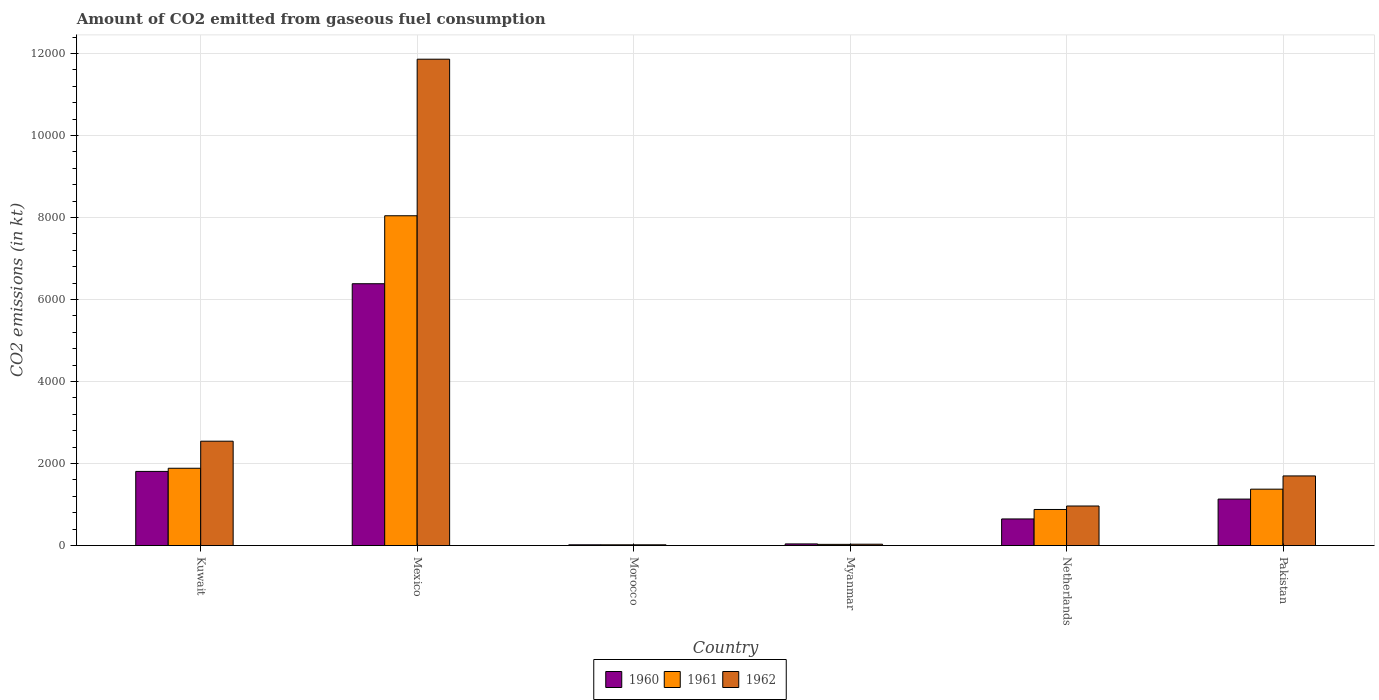How many groups of bars are there?
Your answer should be very brief. 6. Are the number of bars on each tick of the X-axis equal?
Provide a succinct answer. Yes. How many bars are there on the 4th tick from the left?
Offer a very short reply. 3. What is the label of the 2nd group of bars from the left?
Give a very brief answer. Mexico. What is the amount of CO2 emitted in 1961 in Mexico?
Your response must be concise. 8041.73. Across all countries, what is the maximum amount of CO2 emitted in 1962?
Offer a terse response. 1.19e+04. Across all countries, what is the minimum amount of CO2 emitted in 1960?
Provide a succinct answer. 18.34. In which country was the amount of CO2 emitted in 1962 minimum?
Provide a succinct answer. Morocco. What is the total amount of CO2 emitted in 1961 in the graph?
Keep it short and to the point. 1.22e+04. What is the difference between the amount of CO2 emitted in 1960 in Mexico and that in Pakistan?
Your answer should be compact. 5251.14. What is the difference between the amount of CO2 emitted in 1961 in Kuwait and the amount of CO2 emitted in 1962 in Morocco?
Offer a very short reply. 1866.5. What is the average amount of CO2 emitted in 1961 per country?
Offer a very short reply. 2038.24. What is the difference between the amount of CO2 emitted of/in 1961 and amount of CO2 emitted of/in 1962 in Morocco?
Give a very brief answer. 0. In how many countries, is the amount of CO2 emitted in 1961 greater than 10800 kt?
Give a very brief answer. 0. What is the ratio of the amount of CO2 emitted in 1962 in Mexico to that in Myanmar?
Keep it short and to the point. 359.33. Is the amount of CO2 emitted in 1960 in Kuwait less than that in Pakistan?
Make the answer very short. No. Is the difference between the amount of CO2 emitted in 1961 in Mexico and Pakistan greater than the difference between the amount of CO2 emitted in 1962 in Mexico and Pakistan?
Offer a very short reply. No. What is the difference between the highest and the second highest amount of CO2 emitted in 1961?
Offer a terse response. 6156.89. What is the difference between the highest and the lowest amount of CO2 emitted in 1961?
Your answer should be compact. 8023.4. What does the 1st bar from the left in Mexico represents?
Keep it short and to the point. 1960. Is it the case that in every country, the sum of the amount of CO2 emitted in 1962 and amount of CO2 emitted in 1960 is greater than the amount of CO2 emitted in 1961?
Your response must be concise. Yes. Are the values on the major ticks of Y-axis written in scientific E-notation?
Ensure brevity in your answer.  No. Does the graph contain any zero values?
Ensure brevity in your answer.  No. How many legend labels are there?
Keep it short and to the point. 3. How are the legend labels stacked?
Give a very brief answer. Horizontal. What is the title of the graph?
Make the answer very short. Amount of CO2 emitted from gaseous fuel consumption. Does "1985" appear as one of the legend labels in the graph?
Your answer should be very brief. No. What is the label or title of the Y-axis?
Your answer should be compact. CO2 emissions (in kt). What is the CO2 emissions (in kt) of 1960 in Kuwait?
Offer a terse response. 1807.83. What is the CO2 emissions (in kt) of 1961 in Kuwait?
Your answer should be very brief. 1884.84. What is the CO2 emissions (in kt) of 1962 in Kuwait?
Provide a short and direct response. 2544.9. What is the CO2 emissions (in kt) in 1960 in Mexico?
Ensure brevity in your answer.  6384.25. What is the CO2 emissions (in kt) in 1961 in Mexico?
Offer a terse response. 8041.73. What is the CO2 emissions (in kt) of 1962 in Mexico?
Provide a short and direct response. 1.19e+04. What is the CO2 emissions (in kt) in 1960 in Morocco?
Provide a short and direct response. 18.34. What is the CO2 emissions (in kt) of 1961 in Morocco?
Keep it short and to the point. 18.34. What is the CO2 emissions (in kt) in 1962 in Morocco?
Your response must be concise. 18.34. What is the CO2 emissions (in kt) in 1960 in Myanmar?
Offer a very short reply. 40.34. What is the CO2 emissions (in kt) of 1961 in Myanmar?
Provide a short and direct response. 29.34. What is the CO2 emissions (in kt) of 1962 in Myanmar?
Give a very brief answer. 33. What is the CO2 emissions (in kt) of 1960 in Netherlands?
Provide a short and direct response. 649.06. What is the CO2 emissions (in kt) of 1961 in Netherlands?
Your response must be concise. 880.08. What is the CO2 emissions (in kt) of 1962 in Netherlands?
Give a very brief answer. 964.42. What is the CO2 emissions (in kt) in 1960 in Pakistan?
Your response must be concise. 1133.1. What is the CO2 emissions (in kt) in 1961 in Pakistan?
Provide a short and direct response. 1375.12. What is the CO2 emissions (in kt) in 1962 in Pakistan?
Offer a very short reply. 1697.82. Across all countries, what is the maximum CO2 emissions (in kt) in 1960?
Offer a very short reply. 6384.25. Across all countries, what is the maximum CO2 emissions (in kt) in 1961?
Your response must be concise. 8041.73. Across all countries, what is the maximum CO2 emissions (in kt) of 1962?
Your answer should be compact. 1.19e+04. Across all countries, what is the minimum CO2 emissions (in kt) of 1960?
Your answer should be very brief. 18.34. Across all countries, what is the minimum CO2 emissions (in kt) of 1961?
Ensure brevity in your answer.  18.34. Across all countries, what is the minimum CO2 emissions (in kt) in 1962?
Make the answer very short. 18.34. What is the total CO2 emissions (in kt) of 1960 in the graph?
Provide a succinct answer. 1.00e+04. What is the total CO2 emissions (in kt) in 1961 in the graph?
Your answer should be very brief. 1.22e+04. What is the total CO2 emissions (in kt) of 1962 in the graph?
Ensure brevity in your answer.  1.71e+04. What is the difference between the CO2 emissions (in kt) in 1960 in Kuwait and that in Mexico?
Your response must be concise. -4576.42. What is the difference between the CO2 emissions (in kt) of 1961 in Kuwait and that in Mexico?
Your response must be concise. -6156.89. What is the difference between the CO2 emissions (in kt) in 1962 in Kuwait and that in Mexico?
Make the answer very short. -9314.18. What is the difference between the CO2 emissions (in kt) of 1960 in Kuwait and that in Morocco?
Your answer should be compact. 1789.5. What is the difference between the CO2 emissions (in kt) in 1961 in Kuwait and that in Morocco?
Give a very brief answer. 1866.5. What is the difference between the CO2 emissions (in kt) of 1962 in Kuwait and that in Morocco?
Offer a very short reply. 2526.56. What is the difference between the CO2 emissions (in kt) in 1960 in Kuwait and that in Myanmar?
Provide a succinct answer. 1767.49. What is the difference between the CO2 emissions (in kt) in 1961 in Kuwait and that in Myanmar?
Make the answer very short. 1855.5. What is the difference between the CO2 emissions (in kt) of 1962 in Kuwait and that in Myanmar?
Offer a terse response. 2511.89. What is the difference between the CO2 emissions (in kt) in 1960 in Kuwait and that in Netherlands?
Your answer should be very brief. 1158.77. What is the difference between the CO2 emissions (in kt) in 1961 in Kuwait and that in Netherlands?
Offer a terse response. 1004.76. What is the difference between the CO2 emissions (in kt) of 1962 in Kuwait and that in Netherlands?
Your response must be concise. 1580.48. What is the difference between the CO2 emissions (in kt) of 1960 in Kuwait and that in Pakistan?
Ensure brevity in your answer.  674.73. What is the difference between the CO2 emissions (in kt) in 1961 in Kuwait and that in Pakistan?
Provide a succinct answer. 509.71. What is the difference between the CO2 emissions (in kt) of 1962 in Kuwait and that in Pakistan?
Make the answer very short. 847.08. What is the difference between the CO2 emissions (in kt) of 1960 in Mexico and that in Morocco?
Provide a succinct answer. 6365.91. What is the difference between the CO2 emissions (in kt) of 1961 in Mexico and that in Morocco?
Your answer should be very brief. 8023.4. What is the difference between the CO2 emissions (in kt) of 1962 in Mexico and that in Morocco?
Give a very brief answer. 1.18e+04. What is the difference between the CO2 emissions (in kt) in 1960 in Mexico and that in Myanmar?
Provide a succinct answer. 6343.91. What is the difference between the CO2 emissions (in kt) of 1961 in Mexico and that in Myanmar?
Give a very brief answer. 8012.4. What is the difference between the CO2 emissions (in kt) of 1962 in Mexico and that in Myanmar?
Ensure brevity in your answer.  1.18e+04. What is the difference between the CO2 emissions (in kt) in 1960 in Mexico and that in Netherlands?
Provide a short and direct response. 5735.19. What is the difference between the CO2 emissions (in kt) of 1961 in Mexico and that in Netherlands?
Provide a succinct answer. 7161.65. What is the difference between the CO2 emissions (in kt) in 1962 in Mexico and that in Netherlands?
Provide a short and direct response. 1.09e+04. What is the difference between the CO2 emissions (in kt) of 1960 in Mexico and that in Pakistan?
Offer a terse response. 5251.14. What is the difference between the CO2 emissions (in kt) in 1961 in Mexico and that in Pakistan?
Your response must be concise. 6666.61. What is the difference between the CO2 emissions (in kt) of 1962 in Mexico and that in Pakistan?
Your answer should be very brief. 1.02e+04. What is the difference between the CO2 emissions (in kt) in 1960 in Morocco and that in Myanmar?
Offer a terse response. -22. What is the difference between the CO2 emissions (in kt) of 1961 in Morocco and that in Myanmar?
Provide a succinct answer. -11. What is the difference between the CO2 emissions (in kt) of 1962 in Morocco and that in Myanmar?
Provide a short and direct response. -14.67. What is the difference between the CO2 emissions (in kt) in 1960 in Morocco and that in Netherlands?
Provide a succinct answer. -630.72. What is the difference between the CO2 emissions (in kt) of 1961 in Morocco and that in Netherlands?
Provide a succinct answer. -861.75. What is the difference between the CO2 emissions (in kt) of 1962 in Morocco and that in Netherlands?
Keep it short and to the point. -946.09. What is the difference between the CO2 emissions (in kt) of 1960 in Morocco and that in Pakistan?
Your answer should be very brief. -1114.77. What is the difference between the CO2 emissions (in kt) of 1961 in Morocco and that in Pakistan?
Offer a terse response. -1356.79. What is the difference between the CO2 emissions (in kt) in 1962 in Morocco and that in Pakistan?
Offer a very short reply. -1679.49. What is the difference between the CO2 emissions (in kt) of 1960 in Myanmar and that in Netherlands?
Make the answer very short. -608.72. What is the difference between the CO2 emissions (in kt) in 1961 in Myanmar and that in Netherlands?
Offer a very short reply. -850.74. What is the difference between the CO2 emissions (in kt) in 1962 in Myanmar and that in Netherlands?
Give a very brief answer. -931.42. What is the difference between the CO2 emissions (in kt) of 1960 in Myanmar and that in Pakistan?
Offer a terse response. -1092.77. What is the difference between the CO2 emissions (in kt) of 1961 in Myanmar and that in Pakistan?
Offer a terse response. -1345.79. What is the difference between the CO2 emissions (in kt) in 1962 in Myanmar and that in Pakistan?
Make the answer very short. -1664.82. What is the difference between the CO2 emissions (in kt) of 1960 in Netherlands and that in Pakistan?
Your answer should be very brief. -484.04. What is the difference between the CO2 emissions (in kt) of 1961 in Netherlands and that in Pakistan?
Provide a short and direct response. -495.05. What is the difference between the CO2 emissions (in kt) in 1962 in Netherlands and that in Pakistan?
Offer a terse response. -733.4. What is the difference between the CO2 emissions (in kt) in 1960 in Kuwait and the CO2 emissions (in kt) in 1961 in Mexico?
Make the answer very short. -6233.9. What is the difference between the CO2 emissions (in kt) in 1960 in Kuwait and the CO2 emissions (in kt) in 1962 in Mexico?
Your response must be concise. -1.01e+04. What is the difference between the CO2 emissions (in kt) in 1961 in Kuwait and the CO2 emissions (in kt) in 1962 in Mexico?
Your response must be concise. -9974.24. What is the difference between the CO2 emissions (in kt) in 1960 in Kuwait and the CO2 emissions (in kt) in 1961 in Morocco?
Give a very brief answer. 1789.5. What is the difference between the CO2 emissions (in kt) of 1960 in Kuwait and the CO2 emissions (in kt) of 1962 in Morocco?
Your response must be concise. 1789.5. What is the difference between the CO2 emissions (in kt) in 1961 in Kuwait and the CO2 emissions (in kt) in 1962 in Morocco?
Give a very brief answer. 1866.5. What is the difference between the CO2 emissions (in kt) of 1960 in Kuwait and the CO2 emissions (in kt) of 1961 in Myanmar?
Provide a short and direct response. 1778.49. What is the difference between the CO2 emissions (in kt) of 1960 in Kuwait and the CO2 emissions (in kt) of 1962 in Myanmar?
Provide a succinct answer. 1774.83. What is the difference between the CO2 emissions (in kt) of 1961 in Kuwait and the CO2 emissions (in kt) of 1962 in Myanmar?
Offer a terse response. 1851.84. What is the difference between the CO2 emissions (in kt) in 1960 in Kuwait and the CO2 emissions (in kt) in 1961 in Netherlands?
Offer a very short reply. 927.75. What is the difference between the CO2 emissions (in kt) in 1960 in Kuwait and the CO2 emissions (in kt) in 1962 in Netherlands?
Provide a short and direct response. 843.41. What is the difference between the CO2 emissions (in kt) in 1961 in Kuwait and the CO2 emissions (in kt) in 1962 in Netherlands?
Give a very brief answer. 920.42. What is the difference between the CO2 emissions (in kt) of 1960 in Kuwait and the CO2 emissions (in kt) of 1961 in Pakistan?
Offer a terse response. 432.71. What is the difference between the CO2 emissions (in kt) of 1960 in Kuwait and the CO2 emissions (in kt) of 1962 in Pakistan?
Offer a terse response. 110.01. What is the difference between the CO2 emissions (in kt) in 1961 in Kuwait and the CO2 emissions (in kt) in 1962 in Pakistan?
Your answer should be compact. 187.02. What is the difference between the CO2 emissions (in kt) of 1960 in Mexico and the CO2 emissions (in kt) of 1961 in Morocco?
Offer a very short reply. 6365.91. What is the difference between the CO2 emissions (in kt) of 1960 in Mexico and the CO2 emissions (in kt) of 1962 in Morocco?
Make the answer very short. 6365.91. What is the difference between the CO2 emissions (in kt) in 1961 in Mexico and the CO2 emissions (in kt) in 1962 in Morocco?
Offer a very short reply. 8023.4. What is the difference between the CO2 emissions (in kt) of 1960 in Mexico and the CO2 emissions (in kt) of 1961 in Myanmar?
Offer a terse response. 6354.91. What is the difference between the CO2 emissions (in kt) of 1960 in Mexico and the CO2 emissions (in kt) of 1962 in Myanmar?
Keep it short and to the point. 6351.24. What is the difference between the CO2 emissions (in kt) in 1961 in Mexico and the CO2 emissions (in kt) in 1962 in Myanmar?
Your answer should be compact. 8008.73. What is the difference between the CO2 emissions (in kt) in 1960 in Mexico and the CO2 emissions (in kt) in 1961 in Netherlands?
Ensure brevity in your answer.  5504.17. What is the difference between the CO2 emissions (in kt) in 1960 in Mexico and the CO2 emissions (in kt) in 1962 in Netherlands?
Give a very brief answer. 5419.83. What is the difference between the CO2 emissions (in kt) in 1961 in Mexico and the CO2 emissions (in kt) in 1962 in Netherlands?
Make the answer very short. 7077.31. What is the difference between the CO2 emissions (in kt) of 1960 in Mexico and the CO2 emissions (in kt) of 1961 in Pakistan?
Provide a short and direct response. 5009.12. What is the difference between the CO2 emissions (in kt) in 1960 in Mexico and the CO2 emissions (in kt) in 1962 in Pakistan?
Your answer should be compact. 4686.43. What is the difference between the CO2 emissions (in kt) of 1961 in Mexico and the CO2 emissions (in kt) of 1962 in Pakistan?
Offer a terse response. 6343.91. What is the difference between the CO2 emissions (in kt) in 1960 in Morocco and the CO2 emissions (in kt) in 1961 in Myanmar?
Your response must be concise. -11. What is the difference between the CO2 emissions (in kt) in 1960 in Morocco and the CO2 emissions (in kt) in 1962 in Myanmar?
Your answer should be very brief. -14.67. What is the difference between the CO2 emissions (in kt) of 1961 in Morocco and the CO2 emissions (in kt) of 1962 in Myanmar?
Provide a short and direct response. -14.67. What is the difference between the CO2 emissions (in kt) in 1960 in Morocco and the CO2 emissions (in kt) in 1961 in Netherlands?
Your answer should be compact. -861.75. What is the difference between the CO2 emissions (in kt) of 1960 in Morocco and the CO2 emissions (in kt) of 1962 in Netherlands?
Your answer should be compact. -946.09. What is the difference between the CO2 emissions (in kt) of 1961 in Morocco and the CO2 emissions (in kt) of 1962 in Netherlands?
Your answer should be compact. -946.09. What is the difference between the CO2 emissions (in kt) of 1960 in Morocco and the CO2 emissions (in kt) of 1961 in Pakistan?
Provide a succinct answer. -1356.79. What is the difference between the CO2 emissions (in kt) in 1960 in Morocco and the CO2 emissions (in kt) in 1962 in Pakistan?
Give a very brief answer. -1679.49. What is the difference between the CO2 emissions (in kt) in 1961 in Morocco and the CO2 emissions (in kt) in 1962 in Pakistan?
Offer a very short reply. -1679.49. What is the difference between the CO2 emissions (in kt) in 1960 in Myanmar and the CO2 emissions (in kt) in 1961 in Netherlands?
Your answer should be compact. -839.74. What is the difference between the CO2 emissions (in kt) in 1960 in Myanmar and the CO2 emissions (in kt) in 1962 in Netherlands?
Give a very brief answer. -924.08. What is the difference between the CO2 emissions (in kt) in 1961 in Myanmar and the CO2 emissions (in kt) in 1962 in Netherlands?
Your answer should be very brief. -935.09. What is the difference between the CO2 emissions (in kt) in 1960 in Myanmar and the CO2 emissions (in kt) in 1961 in Pakistan?
Your answer should be compact. -1334.79. What is the difference between the CO2 emissions (in kt) of 1960 in Myanmar and the CO2 emissions (in kt) of 1962 in Pakistan?
Your response must be concise. -1657.48. What is the difference between the CO2 emissions (in kt) in 1961 in Myanmar and the CO2 emissions (in kt) in 1962 in Pakistan?
Offer a terse response. -1668.48. What is the difference between the CO2 emissions (in kt) in 1960 in Netherlands and the CO2 emissions (in kt) in 1961 in Pakistan?
Your answer should be very brief. -726.07. What is the difference between the CO2 emissions (in kt) in 1960 in Netherlands and the CO2 emissions (in kt) in 1962 in Pakistan?
Your answer should be compact. -1048.76. What is the difference between the CO2 emissions (in kt) in 1961 in Netherlands and the CO2 emissions (in kt) in 1962 in Pakistan?
Your answer should be very brief. -817.74. What is the average CO2 emissions (in kt) in 1960 per country?
Offer a very short reply. 1672.15. What is the average CO2 emissions (in kt) in 1961 per country?
Give a very brief answer. 2038.24. What is the average CO2 emissions (in kt) in 1962 per country?
Ensure brevity in your answer.  2852.93. What is the difference between the CO2 emissions (in kt) of 1960 and CO2 emissions (in kt) of 1961 in Kuwait?
Ensure brevity in your answer.  -77.01. What is the difference between the CO2 emissions (in kt) of 1960 and CO2 emissions (in kt) of 1962 in Kuwait?
Make the answer very short. -737.07. What is the difference between the CO2 emissions (in kt) of 1961 and CO2 emissions (in kt) of 1962 in Kuwait?
Provide a succinct answer. -660.06. What is the difference between the CO2 emissions (in kt) of 1960 and CO2 emissions (in kt) of 1961 in Mexico?
Give a very brief answer. -1657.48. What is the difference between the CO2 emissions (in kt) of 1960 and CO2 emissions (in kt) of 1962 in Mexico?
Your answer should be compact. -5474.83. What is the difference between the CO2 emissions (in kt) in 1961 and CO2 emissions (in kt) in 1962 in Mexico?
Your response must be concise. -3817.35. What is the difference between the CO2 emissions (in kt) in 1961 and CO2 emissions (in kt) in 1962 in Morocco?
Ensure brevity in your answer.  0. What is the difference between the CO2 emissions (in kt) in 1960 and CO2 emissions (in kt) in 1961 in Myanmar?
Offer a terse response. 11. What is the difference between the CO2 emissions (in kt) of 1960 and CO2 emissions (in kt) of 1962 in Myanmar?
Provide a succinct answer. 7.33. What is the difference between the CO2 emissions (in kt) in 1961 and CO2 emissions (in kt) in 1962 in Myanmar?
Make the answer very short. -3.67. What is the difference between the CO2 emissions (in kt) of 1960 and CO2 emissions (in kt) of 1961 in Netherlands?
Your answer should be very brief. -231.02. What is the difference between the CO2 emissions (in kt) of 1960 and CO2 emissions (in kt) of 1962 in Netherlands?
Ensure brevity in your answer.  -315.36. What is the difference between the CO2 emissions (in kt) in 1961 and CO2 emissions (in kt) in 1962 in Netherlands?
Offer a very short reply. -84.34. What is the difference between the CO2 emissions (in kt) of 1960 and CO2 emissions (in kt) of 1961 in Pakistan?
Provide a short and direct response. -242.02. What is the difference between the CO2 emissions (in kt) in 1960 and CO2 emissions (in kt) in 1962 in Pakistan?
Offer a terse response. -564.72. What is the difference between the CO2 emissions (in kt) of 1961 and CO2 emissions (in kt) of 1962 in Pakistan?
Make the answer very short. -322.7. What is the ratio of the CO2 emissions (in kt) in 1960 in Kuwait to that in Mexico?
Provide a short and direct response. 0.28. What is the ratio of the CO2 emissions (in kt) in 1961 in Kuwait to that in Mexico?
Provide a succinct answer. 0.23. What is the ratio of the CO2 emissions (in kt) in 1962 in Kuwait to that in Mexico?
Offer a terse response. 0.21. What is the ratio of the CO2 emissions (in kt) of 1960 in Kuwait to that in Morocco?
Your answer should be very brief. 98.6. What is the ratio of the CO2 emissions (in kt) in 1961 in Kuwait to that in Morocco?
Your answer should be compact. 102.8. What is the ratio of the CO2 emissions (in kt) of 1962 in Kuwait to that in Morocco?
Offer a very short reply. 138.8. What is the ratio of the CO2 emissions (in kt) of 1960 in Kuwait to that in Myanmar?
Offer a terse response. 44.82. What is the ratio of the CO2 emissions (in kt) of 1961 in Kuwait to that in Myanmar?
Your response must be concise. 64.25. What is the ratio of the CO2 emissions (in kt) in 1962 in Kuwait to that in Myanmar?
Your response must be concise. 77.11. What is the ratio of the CO2 emissions (in kt) of 1960 in Kuwait to that in Netherlands?
Offer a terse response. 2.79. What is the ratio of the CO2 emissions (in kt) of 1961 in Kuwait to that in Netherlands?
Your response must be concise. 2.14. What is the ratio of the CO2 emissions (in kt) in 1962 in Kuwait to that in Netherlands?
Your answer should be compact. 2.64. What is the ratio of the CO2 emissions (in kt) of 1960 in Kuwait to that in Pakistan?
Your answer should be very brief. 1.6. What is the ratio of the CO2 emissions (in kt) in 1961 in Kuwait to that in Pakistan?
Keep it short and to the point. 1.37. What is the ratio of the CO2 emissions (in kt) in 1962 in Kuwait to that in Pakistan?
Offer a very short reply. 1.5. What is the ratio of the CO2 emissions (in kt) in 1960 in Mexico to that in Morocco?
Give a very brief answer. 348.2. What is the ratio of the CO2 emissions (in kt) of 1961 in Mexico to that in Morocco?
Your answer should be very brief. 438.6. What is the ratio of the CO2 emissions (in kt) of 1962 in Mexico to that in Morocco?
Ensure brevity in your answer.  646.8. What is the ratio of the CO2 emissions (in kt) in 1960 in Mexico to that in Myanmar?
Your response must be concise. 158.27. What is the ratio of the CO2 emissions (in kt) in 1961 in Mexico to that in Myanmar?
Keep it short and to the point. 274.12. What is the ratio of the CO2 emissions (in kt) in 1962 in Mexico to that in Myanmar?
Provide a succinct answer. 359.33. What is the ratio of the CO2 emissions (in kt) in 1960 in Mexico to that in Netherlands?
Offer a very short reply. 9.84. What is the ratio of the CO2 emissions (in kt) of 1961 in Mexico to that in Netherlands?
Ensure brevity in your answer.  9.14. What is the ratio of the CO2 emissions (in kt) in 1962 in Mexico to that in Netherlands?
Your answer should be compact. 12.3. What is the ratio of the CO2 emissions (in kt) in 1960 in Mexico to that in Pakistan?
Your answer should be compact. 5.63. What is the ratio of the CO2 emissions (in kt) of 1961 in Mexico to that in Pakistan?
Give a very brief answer. 5.85. What is the ratio of the CO2 emissions (in kt) in 1962 in Mexico to that in Pakistan?
Ensure brevity in your answer.  6.98. What is the ratio of the CO2 emissions (in kt) in 1960 in Morocco to that in Myanmar?
Your answer should be very brief. 0.45. What is the ratio of the CO2 emissions (in kt) of 1962 in Morocco to that in Myanmar?
Offer a terse response. 0.56. What is the ratio of the CO2 emissions (in kt) in 1960 in Morocco to that in Netherlands?
Your answer should be very brief. 0.03. What is the ratio of the CO2 emissions (in kt) in 1961 in Morocco to that in Netherlands?
Your response must be concise. 0.02. What is the ratio of the CO2 emissions (in kt) in 1962 in Morocco to that in Netherlands?
Your answer should be very brief. 0.02. What is the ratio of the CO2 emissions (in kt) of 1960 in Morocco to that in Pakistan?
Keep it short and to the point. 0.02. What is the ratio of the CO2 emissions (in kt) of 1961 in Morocco to that in Pakistan?
Offer a very short reply. 0.01. What is the ratio of the CO2 emissions (in kt) of 1962 in Morocco to that in Pakistan?
Make the answer very short. 0.01. What is the ratio of the CO2 emissions (in kt) of 1960 in Myanmar to that in Netherlands?
Your response must be concise. 0.06. What is the ratio of the CO2 emissions (in kt) of 1962 in Myanmar to that in Netherlands?
Your response must be concise. 0.03. What is the ratio of the CO2 emissions (in kt) in 1960 in Myanmar to that in Pakistan?
Your response must be concise. 0.04. What is the ratio of the CO2 emissions (in kt) in 1961 in Myanmar to that in Pakistan?
Your answer should be very brief. 0.02. What is the ratio of the CO2 emissions (in kt) in 1962 in Myanmar to that in Pakistan?
Provide a succinct answer. 0.02. What is the ratio of the CO2 emissions (in kt) in 1960 in Netherlands to that in Pakistan?
Your response must be concise. 0.57. What is the ratio of the CO2 emissions (in kt) of 1961 in Netherlands to that in Pakistan?
Your response must be concise. 0.64. What is the ratio of the CO2 emissions (in kt) in 1962 in Netherlands to that in Pakistan?
Offer a terse response. 0.57. What is the difference between the highest and the second highest CO2 emissions (in kt) of 1960?
Your response must be concise. 4576.42. What is the difference between the highest and the second highest CO2 emissions (in kt) of 1961?
Your answer should be very brief. 6156.89. What is the difference between the highest and the second highest CO2 emissions (in kt) in 1962?
Your response must be concise. 9314.18. What is the difference between the highest and the lowest CO2 emissions (in kt) of 1960?
Your answer should be compact. 6365.91. What is the difference between the highest and the lowest CO2 emissions (in kt) of 1961?
Offer a terse response. 8023.4. What is the difference between the highest and the lowest CO2 emissions (in kt) of 1962?
Your answer should be compact. 1.18e+04. 